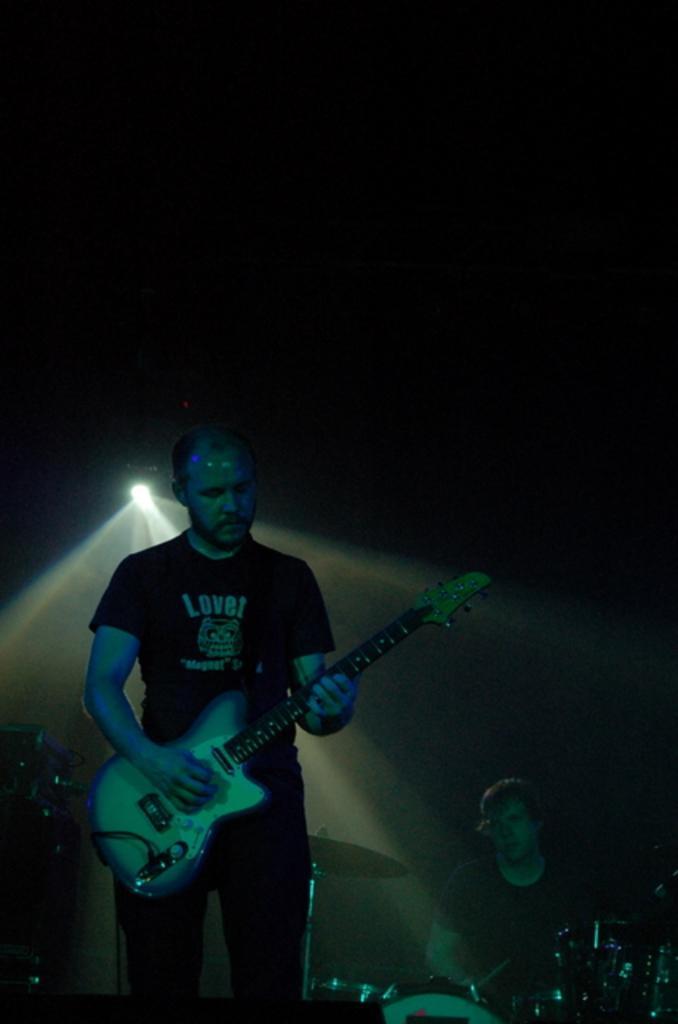Please provide a concise description of this image. The person wearing black shirt is playing guitar and there is other person behind him is playing drums. 